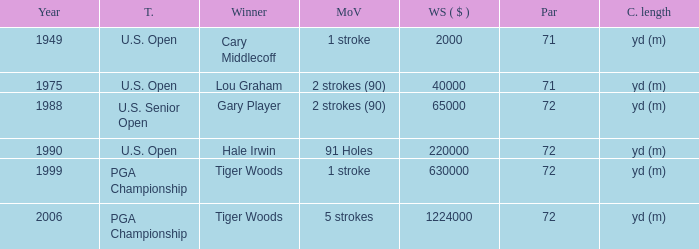When cary middlecoff is the winner how many pars are there? 1.0. 